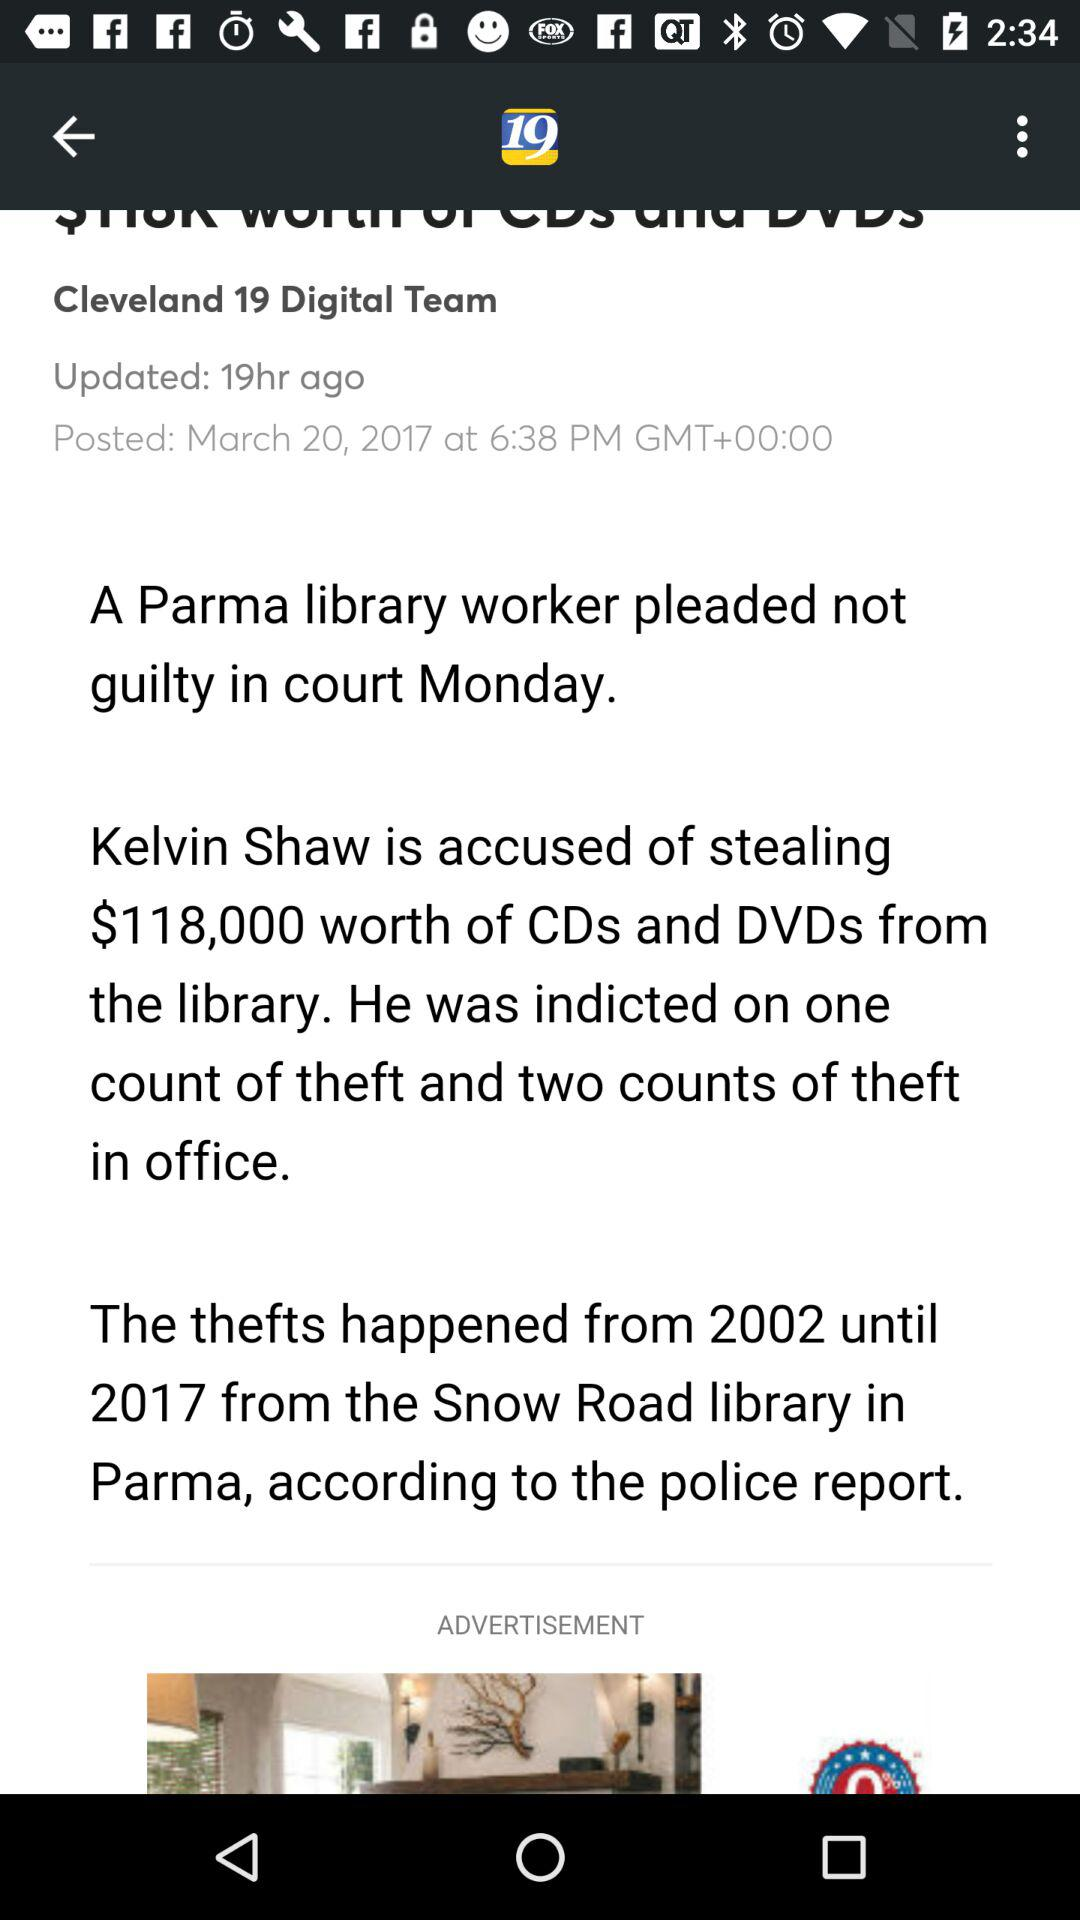Who is the author of the article? The author of the article is "Cleveland 19 Digital Team". 